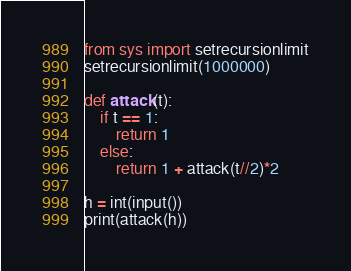Convert code to text. <code><loc_0><loc_0><loc_500><loc_500><_Python_>from sys import setrecursionlimit
setrecursionlimit(1000000)

def attack(t):
    if t == 1:
        return 1
    else:
        return 1 + attack(t//2)*2

h = int(input())
print(attack(h))

</code> 